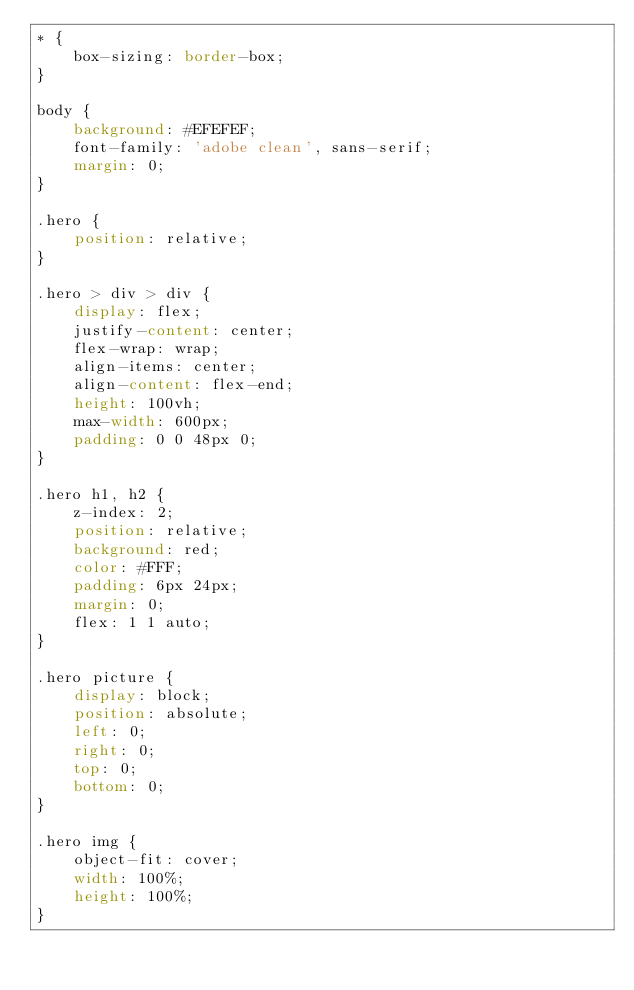<code> <loc_0><loc_0><loc_500><loc_500><_CSS_>* {
    box-sizing: border-box;
}

body {
    background: #EFEFEF;
    font-family: 'adobe clean', sans-serif;
    margin: 0;
}

.hero {
    position: relative;
}

.hero > div > div {
    display: flex;
    justify-content: center;
    flex-wrap: wrap;
    align-items: center;
    align-content: flex-end;
    height: 100vh;
    max-width: 600px;
    padding: 0 0 48px 0;
}

.hero h1, h2 {
    z-index: 2;
    position: relative;
    background: red;
    color: #FFF;
    padding: 6px 24px;
    margin: 0;
    flex: 1 1 auto;
}

.hero picture {
    display: block;
    position: absolute;
    left: 0;
    right: 0;
    top: 0;
    bottom: 0;
}

.hero img {
    object-fit: cover;
    width: 100%;
    height: 100%;
}
</code> 